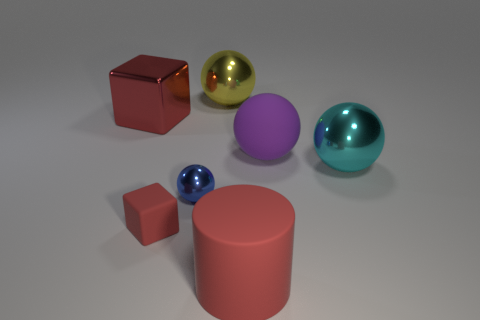What is the color of the large metal thing left of the small object that is to the right of the rubber object to the left of the big yellow metal sphere?
Make the answer very short. Red. What number of rubber things are both behind the large cyan metallic thing and in front of the tiny red object?
Your answer should be very brief. 0. How many balls are either large red rubber objects or big metal things?
Give a very brief answer. 2. Are any large yellow rubber things visible?
Give a very brief answer. No. How many other things are made of the same material as the big yellow ball?
Your answer should be very brief. 3. There is a yellow sphere that is the same size as the cyan metal object; what is its material?
Provide a short and direct response. Metal. There is a big red thing behind the purple matte sphere; is it the same shape as the big yellow metallic thing?
Offer a very short reply. No. Does the large metallic block have the same color as the small sphere?
Your response must be concise. No. What number of things are big red objects behind the red cylinder or tiny purple metal cubes?
Your response must be concise. 1. The yellow object that is the same size as the red metal cube is what shape?
Keep it short and to the point. Sphere. 